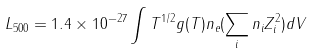<formula> <loc_0><loc_0><loc_500><loc_500>L _ { 5 0 0 } = 1 . 4 \times 1 0 ^ { - 2 7 } \int T ^ { 1 / 2 } g ( T ) n _ { e } ( \sum _ { i } n _ { i } Z _ { i } ^ { 2 } ) d V</formula> 